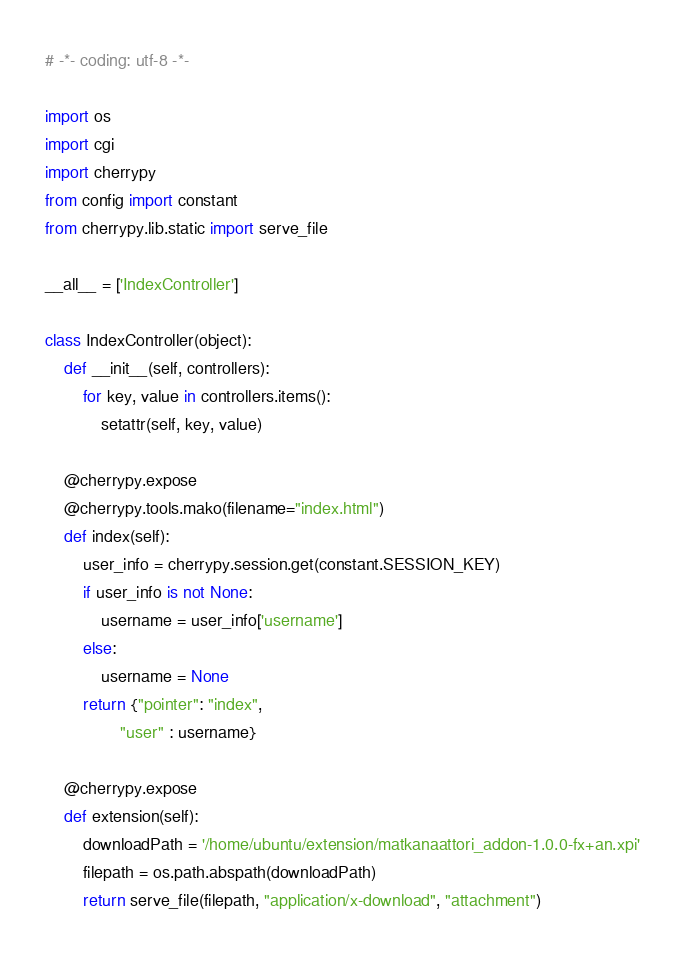<code> <loc_0><loc_0><loc_500><loc_500><_Python_># -*- coding: utf-8 -*-

import os
import cgi
import cherrypy
from config import constant
from cherrypy.lib.static import serve_file

__all__ = ['IndexController']

class IndexController(object):
    def __init__(self, controllers):
    	for key, value in controllers.items():
    		setattr(self, key, value)

    @cherrypy.expose
    @cherrypy.tools.mako(filename="index.html")
    def index(self):
        user_info = cherrypy.session.get(constant.SESSION_KEY)
        if user_info is not None:
            username = user_info['username']
        else:
            username = None
        return {"pointer": "index",
                "user" : username}

    @cherrypy.expose
    def extension(self):
        downloadPath = '/home/ubuntu/extension/matkanaattori_addon-1.0.0-fx+an.xpi'
        filepath = os.path.abspath(downloadPath)
        return serve_file(filepath, "application/x-download", "attachment")
</code> 